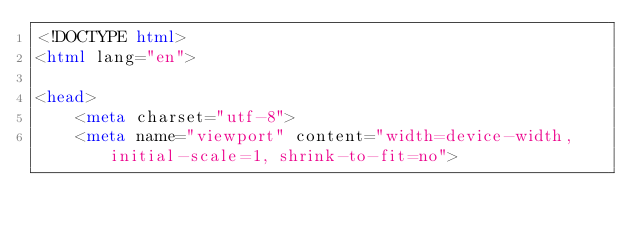<code> <loc_0><loc_0><loc_500><loc_500><_HTML_><!DOCTYPE html>
<html lang="en">

<head>
    <meta charset="utf-8">
    <meta name="viewport" content="width=device-width, initial-scale=1, shrink-to-fit=no"></code> 